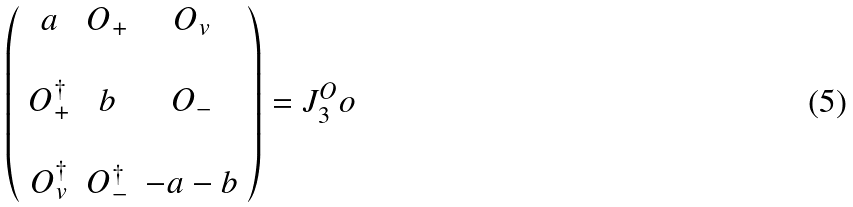Convert formula to latex. <formula><loc_0><loc_0><loc_500><loc_500>\left ( \begin{array} { c c c } a & { O } _ { + } & { O } _ { v } \\ & & \\ { O } _ { + } ^ { \dagger } & b & { O } _ { - } \\ & & \\ { O } _ { v } ^ { \dagger } & { O } _ { - } ^ { \dagger } & - a - b \end{array} \right ) = J _ { 3 } ^ { O } o</formula> 